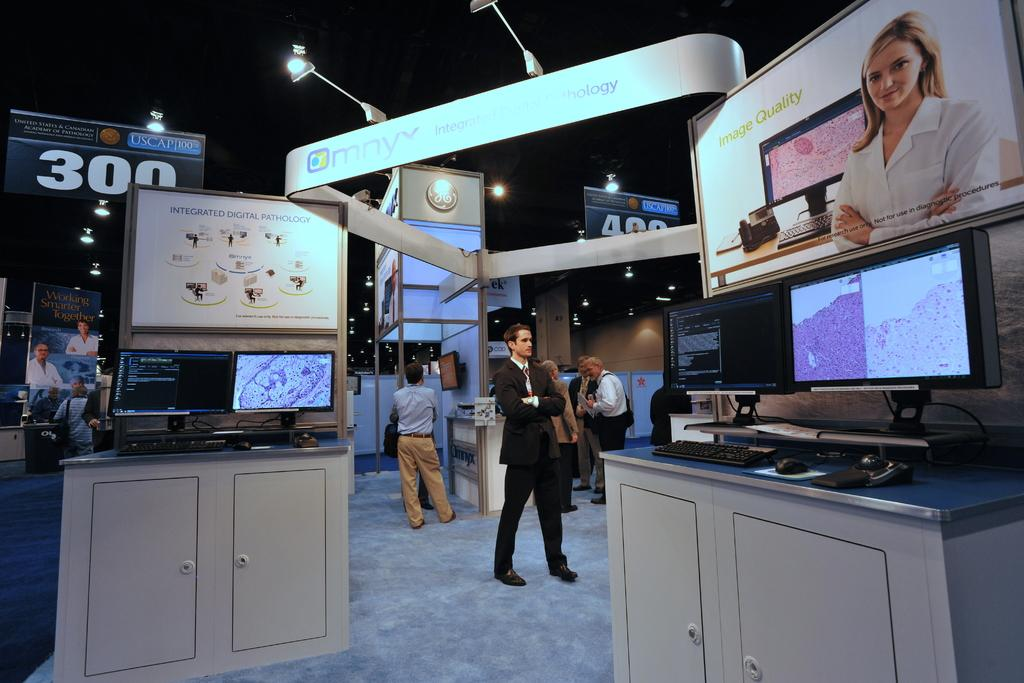<image>
Summarize the visual content of the image. Man standing near some cabinets and monitors with the number 300 in the back. 